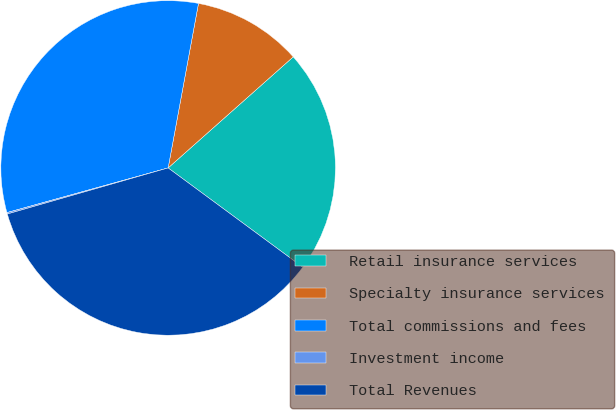Convert chart to OTSL. <chart><loc_0><loc_0><loc_500><loc_500><pie_chart><fcel>Retail insurance services<fcel>Specialty insurance services<fcel>Total commissions and fees<fcel>Investment income<fcel>Total Revenues<nl><fcel>21.67%<fcel>10.54%<fcel>32.21%<fcel>0.14%<fcel>35.45%<nl></chart> 